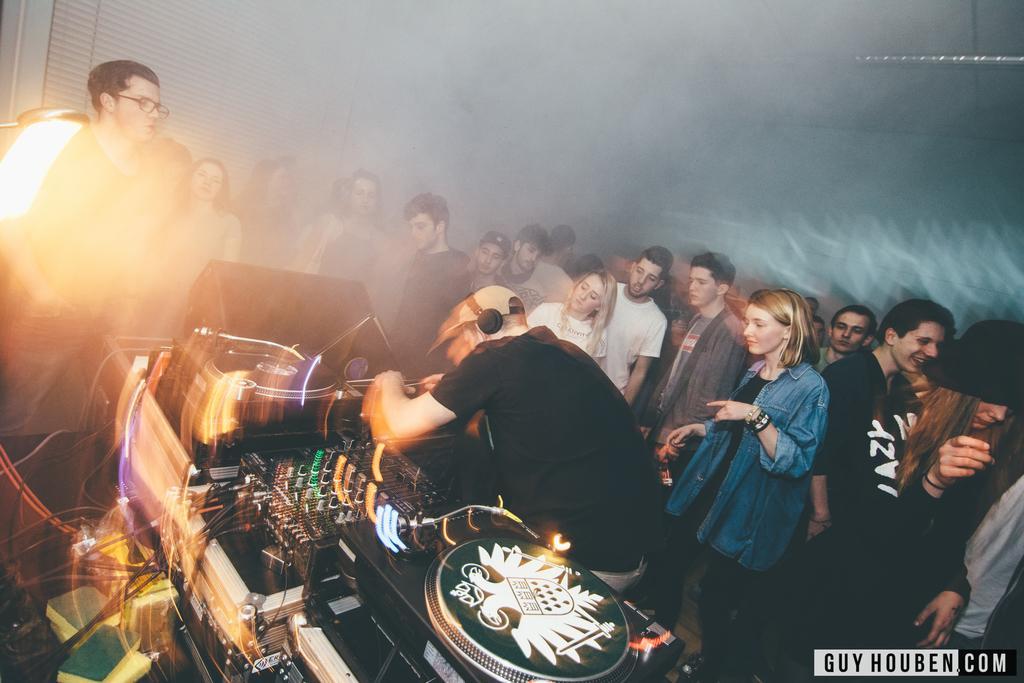In one or two sentences, can you explain what this image depicts? In this image we can see few people in a room, a person is with headphones standing near the music player, there is a window shade on the left side and a light to the ceiling. 